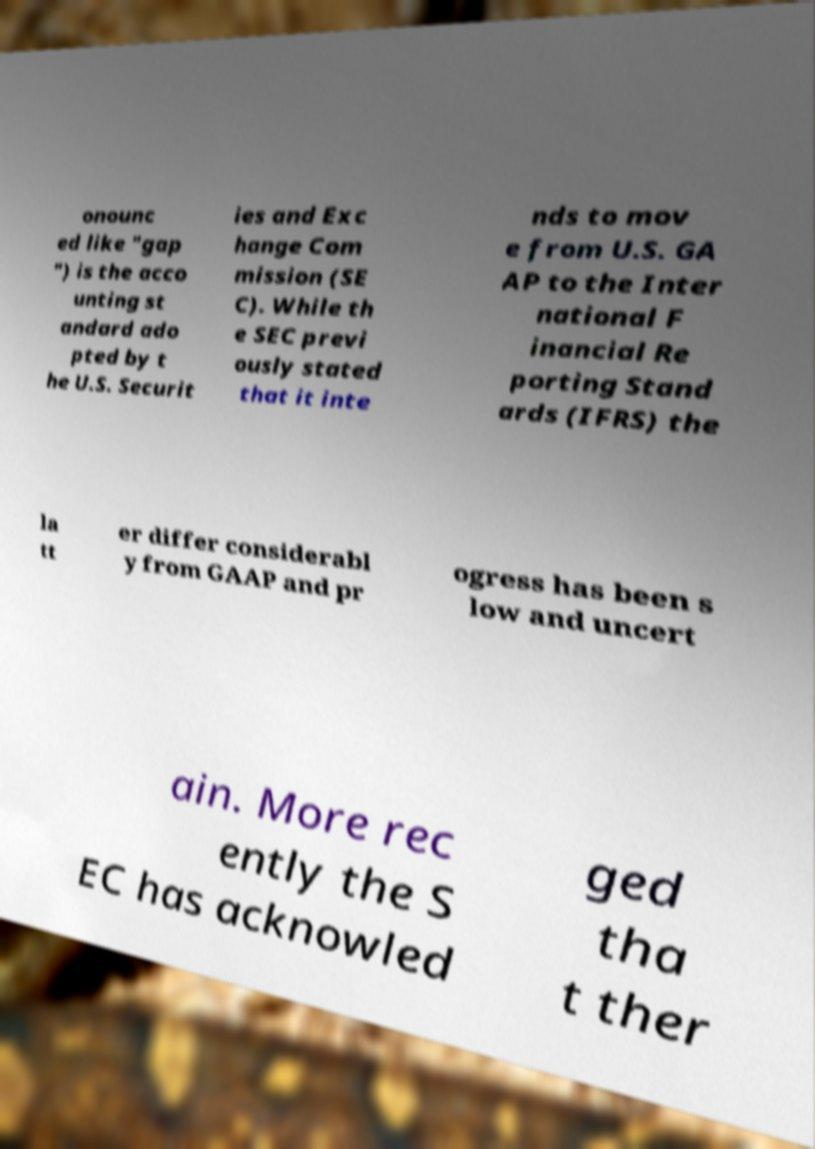What messages or text are displayed in this image? I need them in a readable, typed format. onounc ed like "gap ") is the acco unting st andard ado pted by t he U.S. Securit ies and Exc hange Com mission (SE C). While th e SEC previ ously stated that it inte nds to mov e from U.S. GA AP to the Inter national F inancial Re porting Stand ards (IFRS) the la tt er differ considerabl y from GAAP and pr ogress has been s low and uncert ain. More rec ently the S EC has acknowled ged tha t ther 